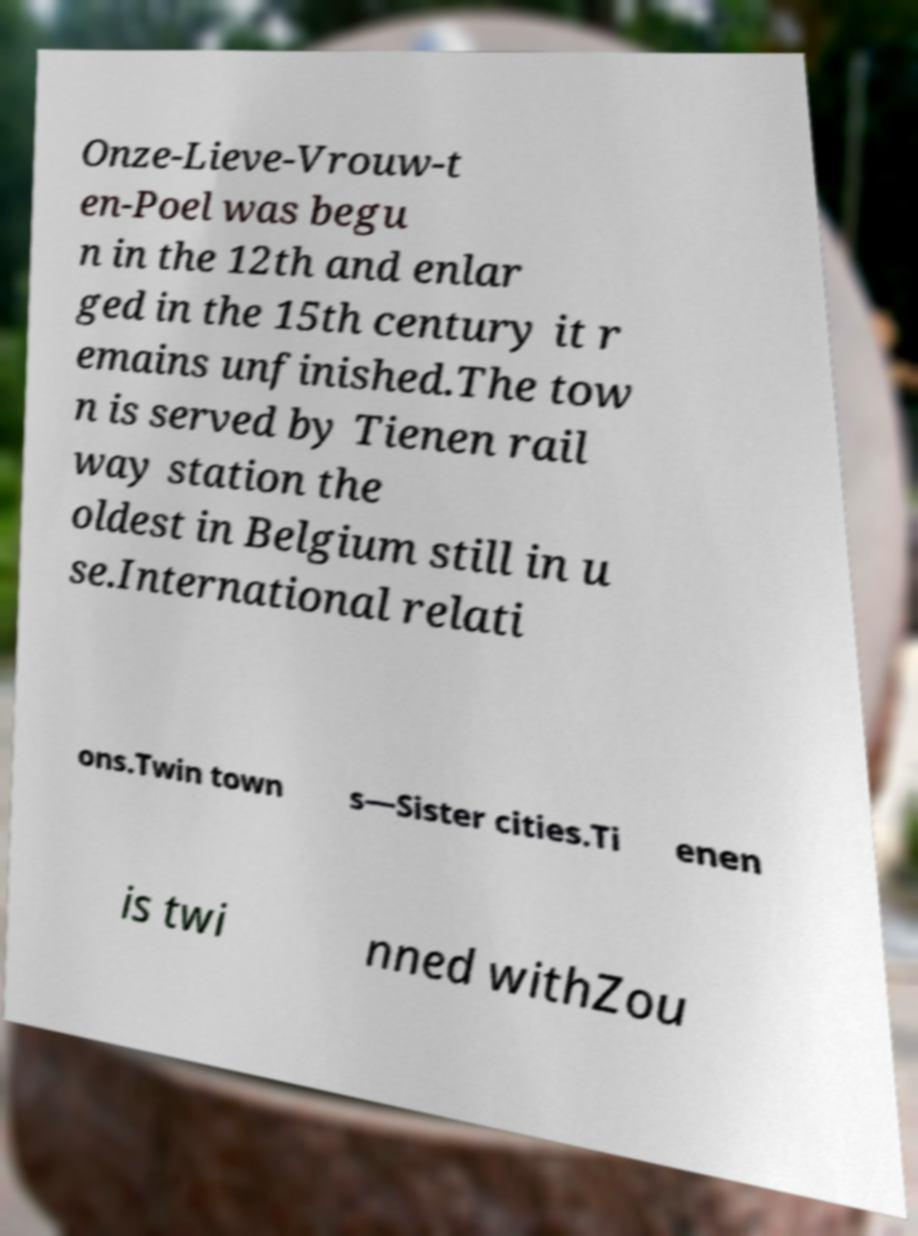What messages or text are displayed in this image? I need them in a readable, typed format. Onze-Lieve-Vrouw-t en-Poel was begu n in the 12th and enlar ged in the 15th century it r emains unfinished.The tow n is served by Tienen rail way station the oldest in Belgium still in u se.International relati ons.Twin town s—Sister cities.Ti enen is twi nned withZou 